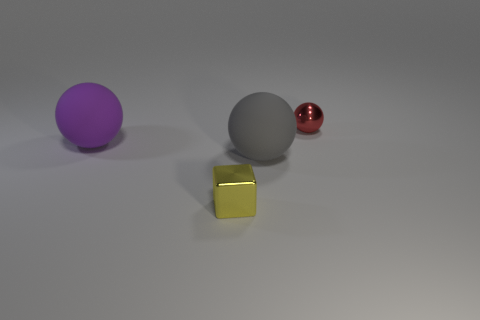Do the purple ball and the metal ball have the same size?
Offer a terse response. No. There is a big gray thing; are there any tiny metallic objects in front of it?
Offer a very short reply. Yes. Do the block and the red sphere have the same material?
Your response must be concise. Yes. What color is the other big thing that is the same shape as the big gray rubber object?
Give a very brief answer. Purple. How many purple things have the same material as the purple ball?
Ensure brevity in your answer.  0. There is a small yellow metallic cube; how many large purple matte objects are right of it?
Offer a terse response. 0. How big is the gray ball?
Give a very brief answer. Large. What is the color of the other sphere that is the same size as the purple ball?
Make the answer very short. Gray. What is the red ball made of?
Keep it short and to the point. Metal. What number of yellow metal things are there?
Give a very brief answer. 1. 